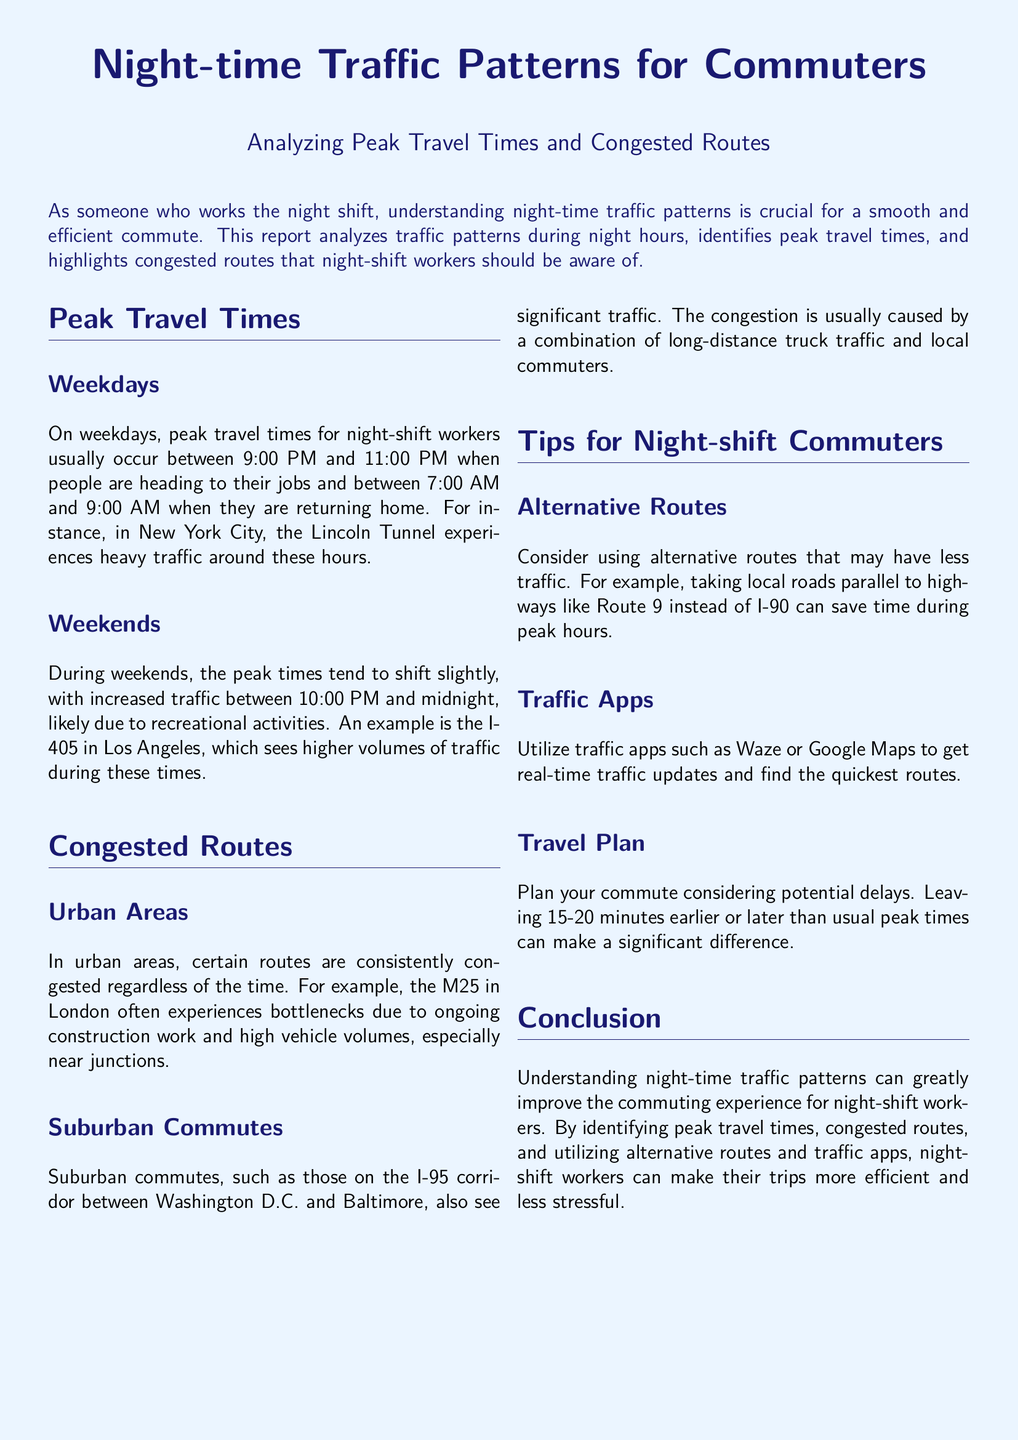What are the peak travel times on weekdays for night-shift workers? The document specifies peak travel times for night-shift workers on weekdays occur between 9:00 PM and 11:00 PM and between 7:00 AM and 9:00 AM.
Answer: 9:00 PM to 11:00 PM, 7:00 AM to 9:00 AM What route experiences heavy traffic in New York City during peak hours? The document mentions the Lincoln Tunnel experiences heavy traffic around these hours.
Answer: Lincoln Tunnel What are the congested routes in urban areas? The document states the M25 in London often experiences bottlenecks due to high vehicle volumes.
Answer: M25 Which highway sees increased traffic on weekends in Los Angeles? The document highlights that the I-405 in Los Angeles sees higher volumes of traffic during weekends.
Answer: I-405 What is a suggested alternative route to avoid traffic during peak hours? The document suggests taking local roads parallel to highways, such as Route 9 instead of I-90.
Answer: Route 9 What is the recommended time adjustment for commuting to avoid delays? The document advises leaving 15-20 minutes earlier or later than usual peak times.
Answer: 15-20 minutes Which traffic apps are recommended for real-time updates? The document mentions Waze or Google Maps for real-time traffic updates.
Answer: Waze, Google Maps What is the main benefit of understanding night-time traffic patterns? The document concludes that understanding these patterns improves the commuting experience for night-shift workers.
Answer: Improved commuting experience What causes congestion on the I-95 corridor? The document states that congestion is usually caused by long-distance truck traffic and local commuters.
Answer: Long-distance truck traffic and local commuters 